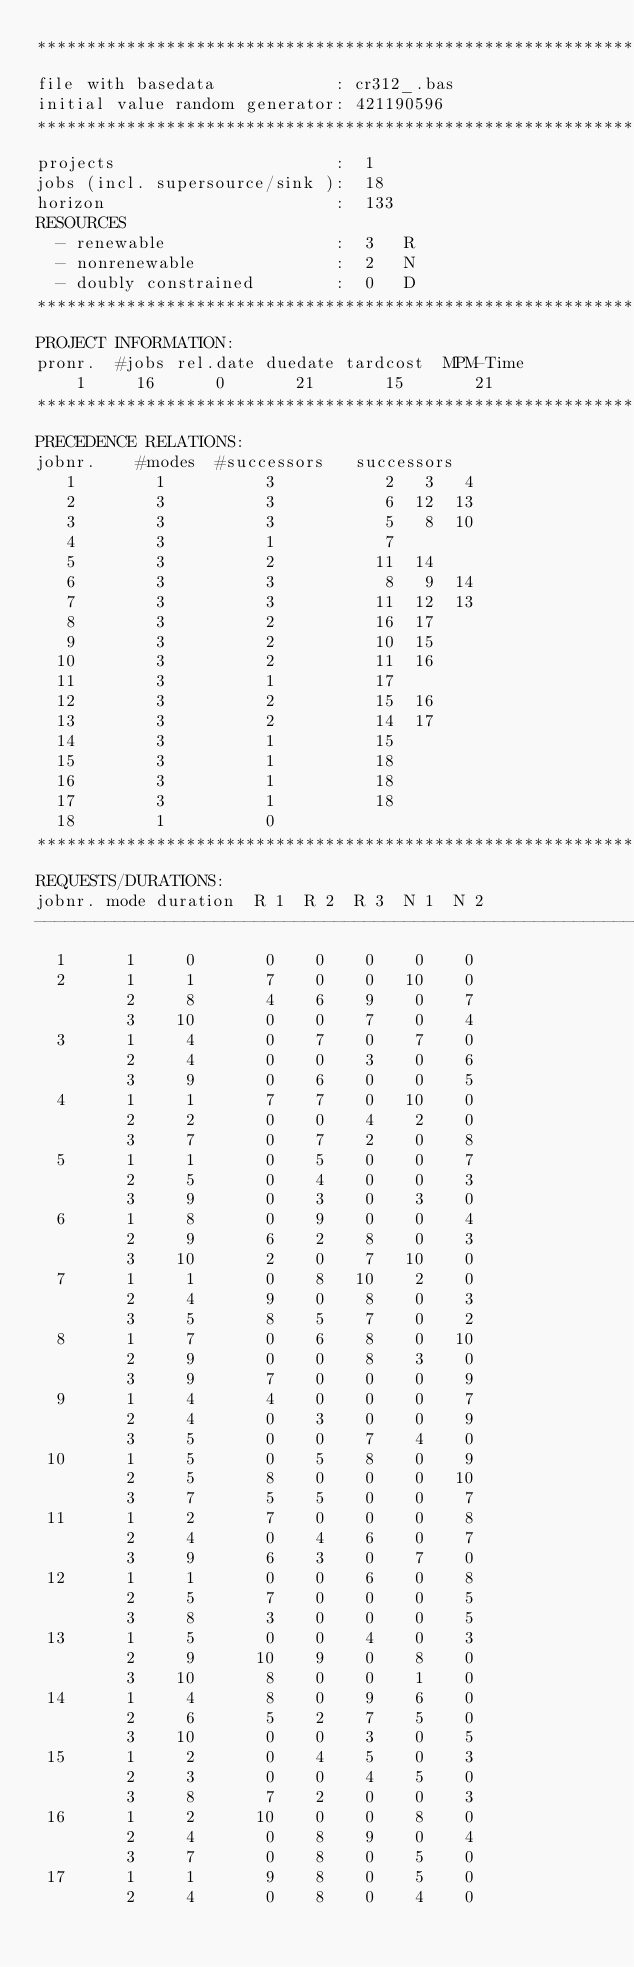<code> <loc_0><loc_0><loc_500><loc_500><_ObjectiveC_>************************************************************************
file with basedata            : cr312_.bas
initial value random generator: 421190596
************************************************************************
projects                      :  1
jobs (incl. supersource/sink ):  18
horizon                       :  133
RESOURCES
  - renewable                 :  3   R
  - nonrenewable              :  2   N
  - doubly constrained        :  0   D
************************************************************************
PROJECT INFORMATION:
pronr.  #jobs rel.date duedate tardcost  MPM-Time
    1     16      0       21       15       21
************************************************************************
PRECEDENCE RELATIONS:
jobnr.    #modes  #successors   successors
   1        1          3           2   3   4
   2        3          3           6  12  13
   3        3          3           5   8  10
   4        3          1           7
   5        3          2          11  14
   6        3          3           8   9  14
   7        3          3          11  12  13
   8        3          2          16  17
   9        3          2          10  15
  10        3          2          11  16
  11        3          1          17
  12        3          2          15  16
  13        3          2          14  17
  14        3          1          15
  15        3          1          18
  16        3          1          18
  17        3          1          18
  18        1          0        
************************************************************************
REQUESTS/DURATIONS:
jobnr. mode duration  R 1  R 2  R 3  N 1  N 2
------------------------------------------------------------------------
  1      1     0       0    0    0    0    0
  2      1     1       7    0    0   10    0
         2     8       4    6    9    0    7
         3    10       0    0    7    0    4
  3      1     4       0    7    0    7    0
         2     4       0    0    3    0    6
         3     9       0    6    0    0    5
  4      1     1       7    7    0   10    0
         2     2       0    0    4    2    0
         3     7       0    7    2    0    8
  5      1     1       0    5    0    0    7
         2     5       0    4    0    0    3
         3     9       0    3    0    3    0
  6      1     8       0    9    0    0    4
         2     9       6    2    8    0    3
         3    10       2    0    7   10    0
  7      1     1       0    8   10    2    0
         2     4       9    0    8    0    3
         3     5       8    5    7    0    2
  8      1     7       0    6    8    0   10
         2     9       0    0    8    3    0
         3     9       7    0    0    0    9
  9      1     4       4    0    0    0    7
         2     4       0    3    0    0    9
         3     5       0    0    7    4    0
 10      1     5       0    5    8    0    9
         2     5       8    0    0    0   10
         3     7       5    5    0    0    7
 11      1     2       7    0    0    0    8
         2     4       0    4    6    0    7
         3     9       6    3    0    7    0
 12      1     1       0    0    6    0    8
         2     5       7    0    0    0    5
         3     8       3    0    0    0    5
 13      1     5       0    0    4    0    3
         2     9      10    9    0    8    0
         3    10       8    0    0    1    0
 14      1     4       8    0    9    6    0
         2     6       5    2    7    5    0
         3    10       0    0    3    0    5
 15      1     2       0    4    5    0    3
         2     3       0    0    4    5    0
         3     8       7    2    0    0    3
 16      1     2      10    0    0    8    0
         2     4       0    8    9    0    4
         3     7       0    8    0    5    0
 17      1     1       9    8    0    5    0
         2     4       0    8    0    4    0</code> 